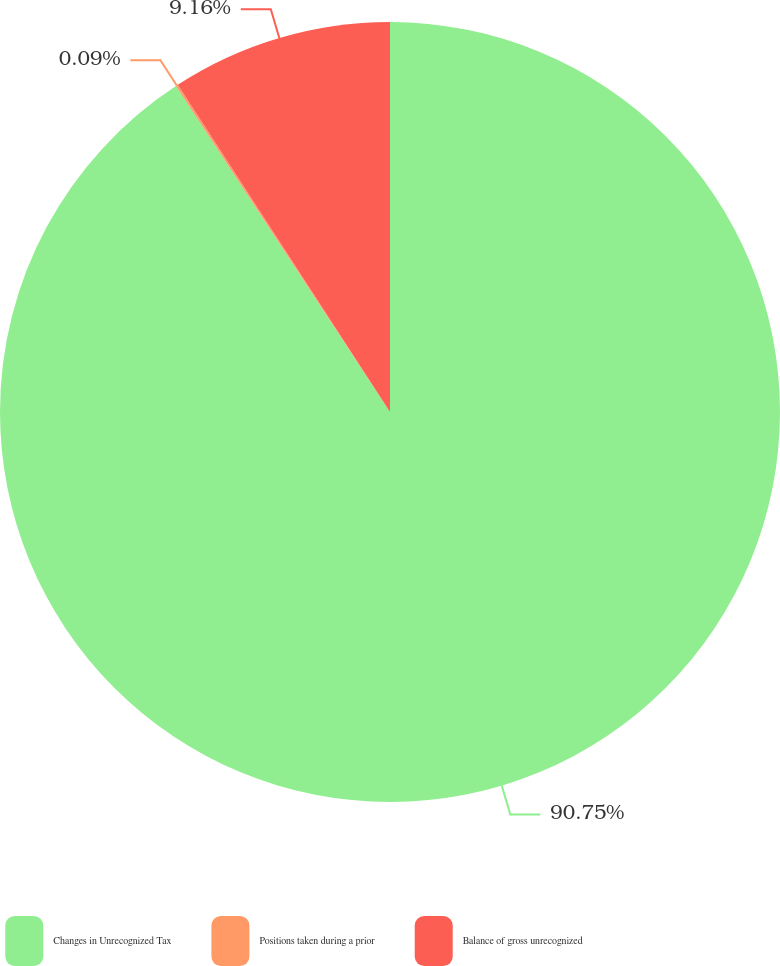<chart> <loc_0><loc_0><loc_500><loc_500><pie_chart><fcel>Changes in Unrecognized Tax<fcel>Positions taken during a prior<fcel>Balance of gross unrecognized<nl><fcel>90.75%<fcel>0.09%<fcel>9.16%<nl></chart> 